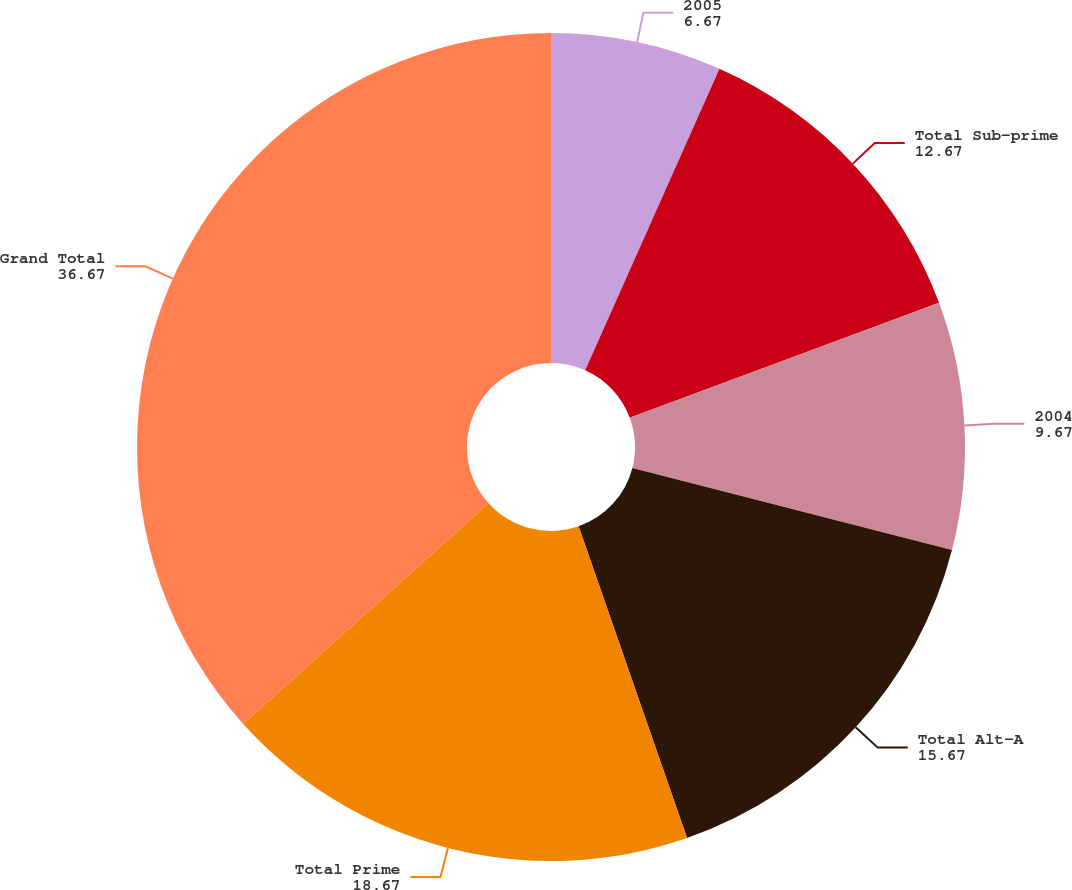Convert chart. <chart><loc_0><loc_0><loc_500><loc_500><pie_chart><fcel>2005<fcel>Total Sub-prime<fcel>2004<fcel>Total Alt-A<fcel>Total Prime<fcel>Grand Total<nl><fcel>6.67%<fcel>12.67%<fcel>9.67%<fcel>15.67%<fcel>18.67%<fcel>36.67%<nl></chart> 